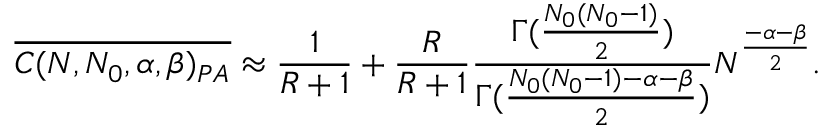Convert formula to latex. <formula><loc_0><loc_0><loc_500><loc_500>\overline { { C ( N , N _ { 0 } , \alpha , \beta ) _ { P A } } } \approx \frac { 1 } { R + 1 } + \frac { R } { R + 1 } \frac { \Gamma ( \frac { N _ { 0 } ( N _ { 0 } - 1 ) } { 2 } ) } { \Gamma ( \frac { N _ { 0 } ( N _ { 0 } - 1 ) - \alpha - \beta } { 2 } ) } N ^ { \frac { - \alpha - \beta } { 2 } } .</formula> 